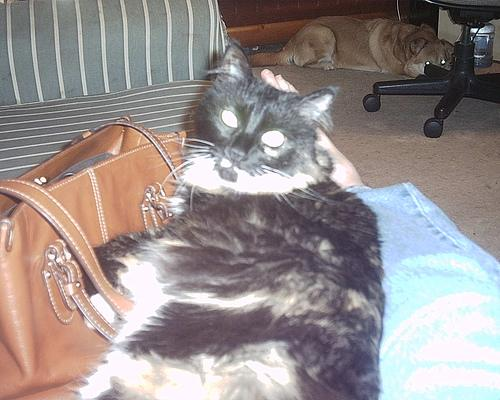Why are the animals eyes white?

Choices:
A) light reflection
B) blindness
C) eye disease
D) photoshopped light reflection 